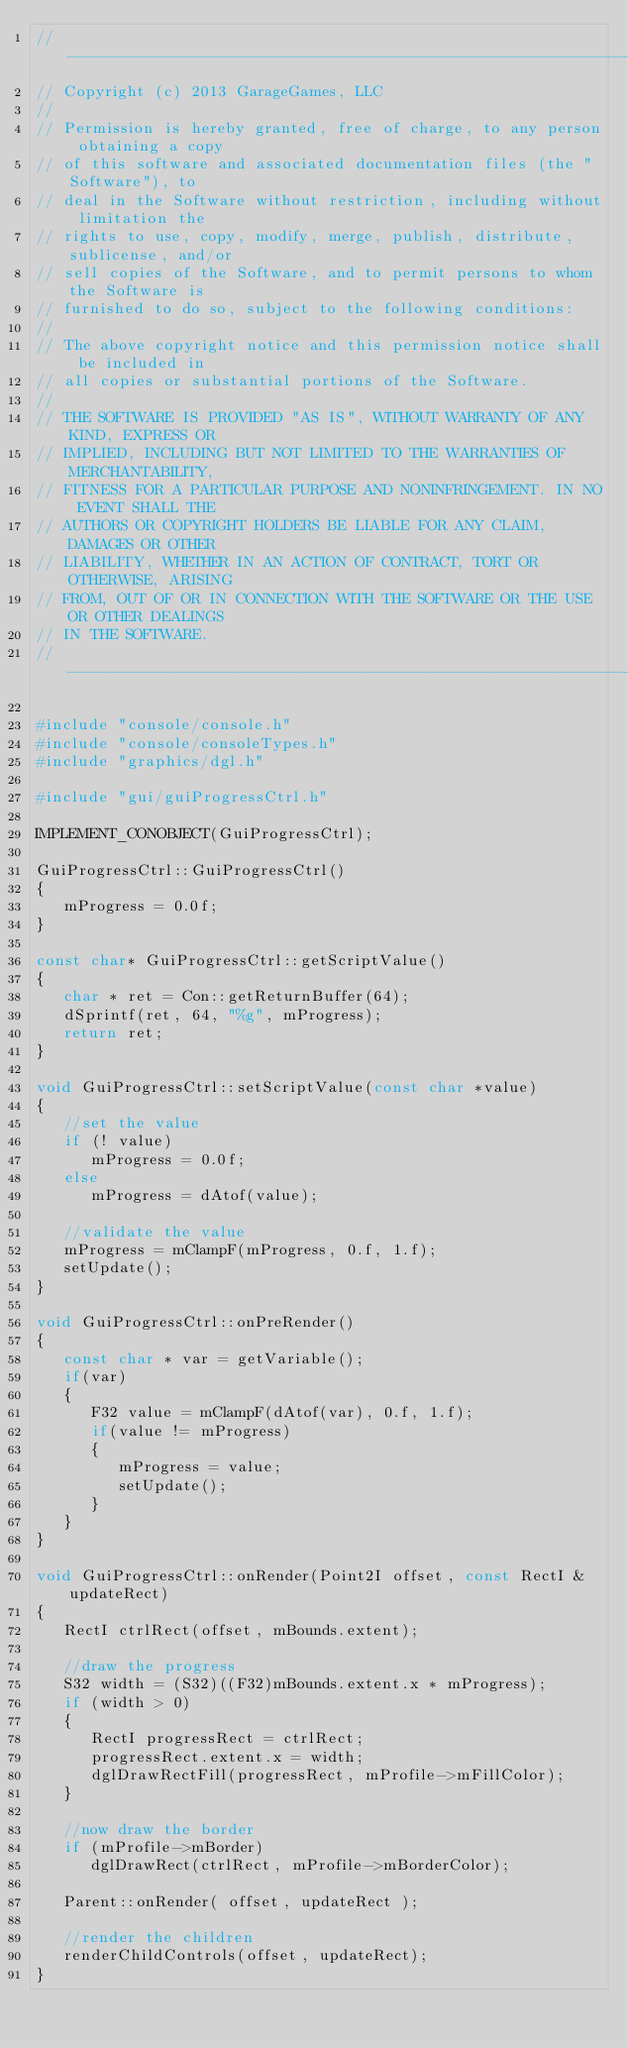<code> <loc_0><loc_0><loc_500><loc_500><_C++_>//-----------------------------------------------------------------------------
// Copyright (c) 2013 GarageGames, LLC
//
// Permission is hereby granted, free of charge, to any person obtaining a copy
// of this software and associated documentation files (the "Software"), to
// deal in the Software without restriction, including without limitation the
// rights to use, copy, modify, merge, publish, distribute, sublicense, and/or
// sell copies of the Software, and to permit persons to whom the Software is
// furnished to do so, subject to the following conditions:
//
// The above copyright notice and this permission notice shall be included in
// all copies or substantial portions of the Software.
//
// THE SOFTWARE IS PROVIDED "AS IS", WITHOUT WARRANTY OF ANY KIND, EXPRESS OR
// IMPLIED, INCLUDING BUT NOT LIMITED TO THE WARRANTIES OF MERCHANTABILITY,
// FITNESS FOR A PARTICULAR PURPOSE AND NONINFRINGEMENT. IN NO EVENT SHALL THE
// AUTHORS OR COPYRIGHT HOLDERS BE LIABLE FOR ANY CLAIM, DAMAGES OR OTHER
// LIABILITY, WHETHER IN AN ACTION OF CONTRACT, TORT OR OTHERWISE, ARISING
// FROM, OUT OF OR IN CONNECTION WITH THE SOFTWARE OR THE USE OR OTHER DEALINGS
// IN THE SOFTWARE.
//-----------------------------------------------------------------------------

#include "console/console.h"
#include "console/consoleTypes.h"
#include "graphics/dgl.h"

#include "gui/guiProgressCtrl.h"

IMPLEMENT_CONOBJECT(GuiProgressCtrl);

GuiProgressCtrl::GuiProgressCtrl()
{
   mProgress = 0.0f;
}

const char* GuiProgressCtrl::getScriptValue()
{
   char * ret = Con::getReturnBuffer(64);
   dSprintf(ret, 64, "%g", mProgress);
   return ret;
}

void GuiProgressCtrl::setScriptValue(const char *value)
{
   //set the value
   if (! value)
      mProgress = 0.0f;
   else
      mProgress = dAtof(value);

   //validate the value
   mProgress = mClampF(mProgress, 0.f, 1.f);
   setUpdate();
}

void GuiProgressCtrl::onPreRender()
{
   const char * var = getVariable();
   if(var)
   {
      F32 value = mClampF(dAtof(var), 0.f, 1.f);
      if(value != mProgress)
      {
         mProgress = value;
         setUpdate();
      }
   }
}

void GuiProgressCtrl::onRender(Point2I offset, const RectI &updateRect)
{
   RectI ctrlRect(offset, mBounds.extent);

   //draw the progress
   S32 width = (S32)((F32)mBounds.extent.x * mProgress);
   if (width > 0)
   {
      RectI progressRect = ctrlRect;
      progressRect.extent.x = width;
      dglDrawRectFill(progressRect, mProfile->mFillColor);
   }

   //now draw the border
   if (mProfile->mBorder)
      dglDrawRect(ctrlRect, mProfile->mBorderColor);

   Parent::onRender( offset, updateRect );

   //render the children
   renderChildControls(offset, updateRect);
}

</code> 